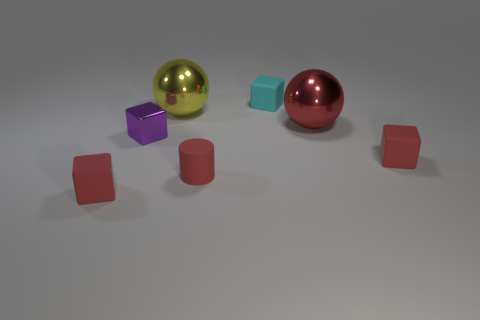Subtract all purple cubes. How many cubes are left? 3 Subtract all cyan balls. How many red cubes are left? 2 Add 1 brown cylinders. How many objects exist? 8 Subtract all yellow spheres. How many spheres are left? 1 Subtract all cylinders. How many objects are left? 6 Add 5 red things. How many red things exist? 9 Subtract 0 green cylinders. How many objects are left? 7 Subtract 1 cylinders. How many cylinders are left? 0 Subtract all yellow cubes. Subtract all brown cylinders. How many cubes are left? 4 Subtract all small cyan blocks. Subtract all large spheres. How many objects are left? 4 